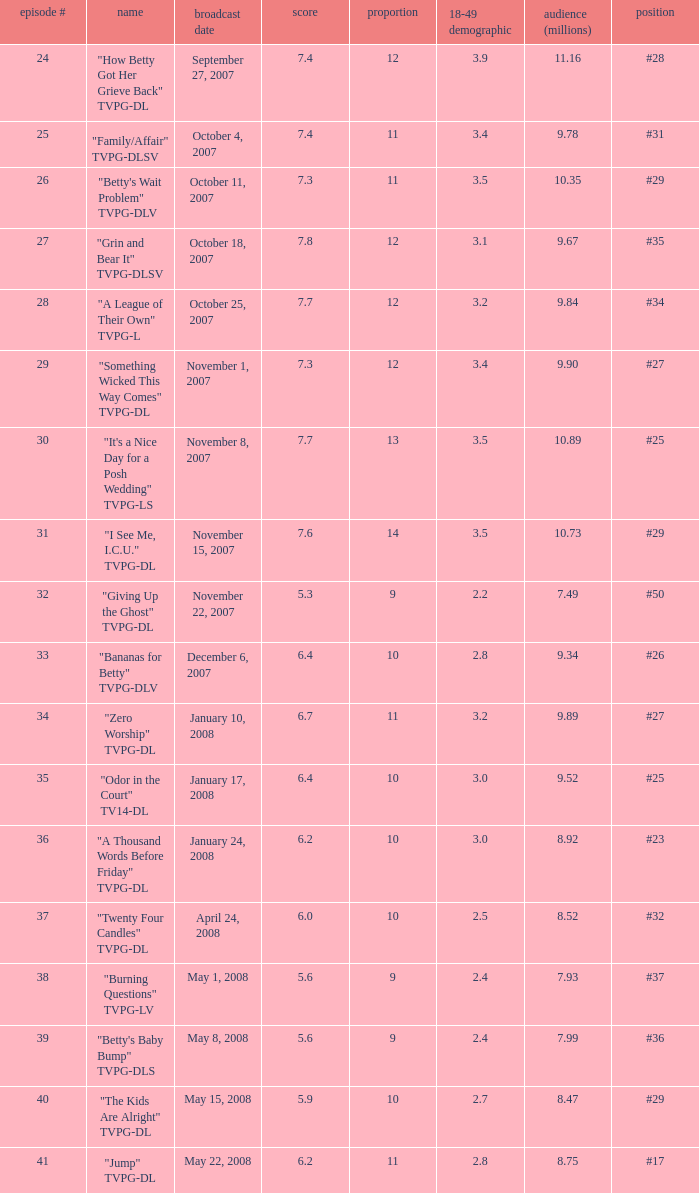What is the Airdate of the episode that ranked #29 and had a share greater than 10? May 15, 2008. 